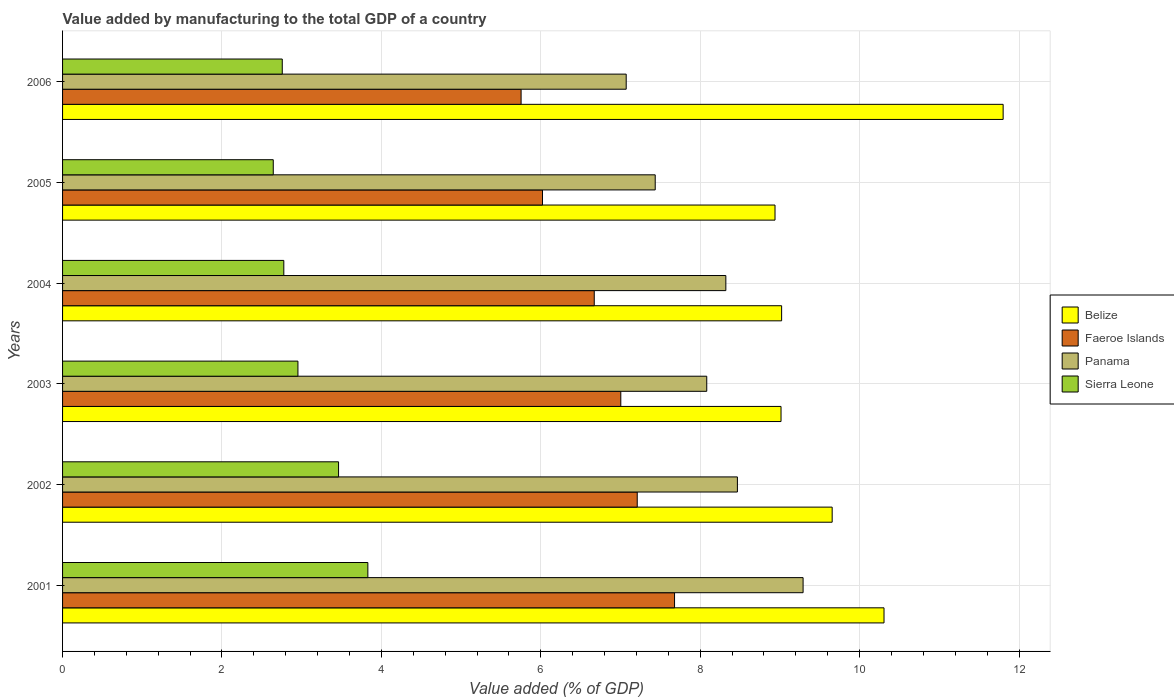How many different coloured bars are there?
Offer a very short reply. 4. How many groups of bars are there?
Offer a terse response. 6. Are the number of bars per tick equal to the number of legend labels?
Provide a short and direct response. Yes. How many bars are there on the 4th tick from the bottom?
Your answer should be very brief. 4. In how many cases, is the number of bars for a given year not equal to the number of legend labels?
Make the answer very short. 0. What is the value added by manufacturing to the total GDP in Faeroe Islands in 2001?
Give a very brief answer. 7.68. Across all years, what is the maximum value added by manufacturing to the total GDP in Sierra Leone?
Give a very brief answer. 3.83. Across all years, what is the minimum value added by manufacturing to the total GDP in Faeroe Islands?
Make the answer very short. 5.75. In which year was the value added by manufacturing to the total GDP in Belize minimum?
Ensure brevity in your answer.  2005. What is the total value added by manufacturing to the total GDP in Panama in the graph?
Give a very brief answer. 48.67. What is the difference between the value added by manufacturing to the total GDP in Sierra Leone in 2002 and that in 2005?
Make the answer very short. 0.82. What is the difference between the value added by manufacturing to the total GDP in Sierra Leone in 2004 and the value added by manufacturing to the total GDP in Faeroe Islands in 2003?
Make the answer very short. -4.23. What is the average value added by manufacturing to the total GDP in Panama per year?
Make the answer very short. 8.11. In the year 2003, what is the difference between the value added by manufacturing to the total GDP in Belize and value added by manufacturing to the total GDP in Faeroe Islands?
Ensure brevity in your answer.  2.01. What is the ratio of the value added by manufacturing to the total GDP in Sierra Leone in 2004 to that in 2005?
Offer a very short reply. 1.05. What is the difference between the highest and the second highest value added by manufacturing to the total GDP in Panama?
Provide a succinct answer. 0.82. What is the difference between the highest and the lowest value added by manufacturing to the total GDP in Belize?
Provide a succinct answer. 2.86. In how many years, is the value added by manufacturing to the total GDP in Panama greater than the average value added by manufacturing to the total GDP in Panama taken over all years?
Offer a terse response. 3. Is it the case that in every year, the sum of the value added by manufacturing to the total GDP in Sierra Leone and value added by manufacturing to the total GDP in Belize is greater than the sum of value added by manufacturing to the total GDP in Panama and value added by manufacturing to the total GDP in Faeroe Islands?
Your answer should be very brief. No. What does the 3rd bar from the top in 2001 represents?
Ensure brevity in your answer.  Faeroe Islands. What does the 4th bar from the bottom in 2005 represents?
Provide a short and direct response. Sierra Leone. Is it the case that in every year, the sum of the value added by manufacturing to the total GDP in Faeroe Islands and value added by manufacturing to the total GDP in Panama is greater than the value added by manufacturing to the total GDP in Belize?
Your response must be concise. Yes. How many bars are there?
Offer a terse response. 24. What is the difference between two consecutive major ticks on the X-axis?
Keep it short and to the point. 2. Does the graph contain grids?
Offer a very short reply. Yes. Where does the legend appear in the graph?
Keep it short and to the point. Center right. How many legend labels are there?
Provide a succinct answer. 4. How are the legend labels stacked?
Provide a short and direct response. Vertical. What is the title of the graph?
Your answer should be very brief. Value added by manufacturing to the total GDP of a country. Does "Panama" appear as one of the legend labels in the graph?
Your answer should be compact. Yes. What is the label or title of the X-axis?
Give a very brief answer. Value added (% of GDP). What is the label or title of the Y-axis?
Give a very brief answer. Years. What is the Value added (% of GDP) of Belize in 2001?
Provide a short and direct response. 10.31. What is the Value added (% of GDP) of Faeroe Islands in 2001?
Make the answer very short. 7.68. What is the Value added (% of GDP) in Panama in 2001?
Offer a very short reply. 9.29. What is the Value added (% of GDP) of Sierra Leone in 2001?
Your answer should be very brief. 3.83. What is the Value added (% of GDP) in Belize in 2002?
Your answer should be very brief. 9.66. What is the Value added (% of GDP) in Faeroe Islands in 2002?
Your answer should be very brief. 7.21. What is the Value added (% of GDP) in Panama in 2002?
Give a very brief answer. 8.47. What is the Value added (% of GDP) in Sierra Leone in 2002?
Provide a short and direct response. 3.46. What is the Value added (% of GDP) of Belize in 2003?
Your answer should be compact. 9.01. What is the Value added (% of GDP) of Faeroe Islands in 2003?
Give a very brief answer. 7. What is the Value added (% of GDP) of Panama in 2003?
Your response must be concise. 8.08. What is the Value added (% of GDP) in Sierra Leone in 2003?
Give a very brief answer. 2.95. What is the Value added (% of GDP) in Belize in 2004?
Give a very brief answer. 9.02. What is the Value added (% of GDP) in Faeroe Islands in 2004?
Offer a very short reply. 6.67. What is the Value added (% of GDP) of Panama in 2004?
Your answer should be compact. 8.32. What is the Value added (% of GDP) of Sierra Leone in 2004?
Make the answer very short. 2.78. What is the Value added (% of GDP) of Belize in 2005?
Make the answer very short. 8.94. What is the Value added (% of GDP) of Faeroe Islands in 2005?
Offer a terse response. 6.02. What is the Value added (% of GDP) in Panama in 2005?
Ensure brevity in your answer.  7.44. What is the Value added (% of GDP) in Sierra Leone in 2005?
Make the answer very short. 2.64. What is the Value added (% of GDP) in Belize in 2006?
Your response must be concise. 11.8. What is the Value added (% of GDP) in Faeroe Islands in 2006?
Offer a terse response. 5.75. What is the Value added (% of GDP) of Panama in 2006?
Ensure brevity in your answer.  7.07. What is the Value added (% of GDP) of Sierra Leone in 2006?
Ensure brevity in your answer.  2.76. Across all years, what is the maximum Value added (% of GDP) of Belize?
Ensure brevity in your answer.  11.8. Across all years, what is the maximum Value added (% of GDP) in Faeroe Islands?
Give a very brief answer. 7.68. Across all years, what is the maximum Value added (% of GDP) in Panama?
Offer a terse response. 9.29. Across all years, what is the maximum Value added (% of GDP) of Sierra Leone?
Ensure brevity in your answer.  3.83. Across all years, what is the minimum Value added (% of GDP) of Belize?
Your answer should be very brief. 8.94. Across all years, what is the minimum Value added (% of GDP) of Faeroe Islands?
Your answer should be compact. 5.75. Across all years, what is the minimum Value added (% of GDP) in Panama?
Your answer should be compact. 7.07. Across all years, what is the minimum Value added (% of GDP) of Sierra Leone?
Provide a short and direct response. 2.64. What is the total Value added (% of GDP) of Belize in the graph?
Your answer should be compact. 58.74. What is the total Value added (% of GDP) of Faeroe Islands in the graph?
Keep it short and to the point. 40.34. What is the total Value added (% of GDP) in Panama in the graph?
Your response must be concise. 48.67. What is the total Value added (% of GDP) in Sierra Leone in the graph?
Provide a short and direct response. 18.42. What is the difference between the Value added (% of GDP) in Belize in 2001 and that in 2002?
Give a very brief answer. 0.65. What is the difference between the Value added (% of GDP) in Faeroe Islands in 2001 and that in 2002?
Ensure brevity in your answer.  0.47. What is the difference between the Value added (% of GDP) of Panama in 2001 and that in 2002?
Make the answer very short. 0.82. What is the difference between the Value added (% of GDP) of Sierra Leone in 2001 and that in 2002?
Ensure brevity in your answer.  0.37. What is the difference between the Value added (% of GDP) in Belize in 2001 and that in 2003?
Your answer should be very brief. 1.29. What is the difference between the Value added (% of GDP) in Faeroe Islands in 2001 and that in 2003?
Give a very brief answer. 0.67. What is the difference between the Value added (% of GDP) in Panama in 2001 and that in 2003?
Your answer should be very brief. 1.21. What is the difference between the Value added (% of GDP) of Sierra Leone in 2001 and that in 2003?
Provide a short and direct response. 0.88. What is the difference between the Value added (% of GDP) in Belize in 2001 and that in 2004?
Make the answer very short. 1.28. What is the difference between the Value added (% of GDP) in Faeroe Islands in 2001 and that in 2004?
Offer a very short reply. 1.01. What is the difference between the Value added (% of GDP) in Panama in 2001 and that in 2004?
Your answer should be very brief. 0.97. What is the difference between the Value added (% of GDP) in Sierra Leone in 2001 and that in 2004?
Give a very brief answer. 1.05. What is the difference between the Value added (% of GDP) of Belize in 2001 and that in 2005?
Your response must be concise. 1.37. What is the difference between the Value added (% of GDP) in Faeroe Islands in 2001 and that in 2005?
Your answer should be compact. 1.66. What is the difference between the Value added (% of GDP) of Panama in 2001 and that in 2005?
Ensure brevity in your answer.  1.86. What is the difference between the Value added (% of GDP) of Sierra Leone in 2001 and that in 2005?
Make the answer very short. 1.19. What is the difference between the Value added (% of GDP) in Belize in 2001 and that in 2006?
Your answer should be compact. -1.49. What is the difference between the Value added (% of GDP) in Faeroe Islands in 2001 and that in 2006?
Offer a terse response. 1.93. What is the difference between the Value added (% of GDP) of Panama in 2001 and that in 2006?
Give a very brief answer. 2.22. What is the difference between the Value added (% of GDP) of Sierra Leone in 2001 and that in 2006?
Keep it short and to the point. 1.07. What is the difference between the Value added (% of GDP) in Belize in 2002 and that in 2003?
Your answer should be compact. 0.64. What is the difference between the Value added (% of GDP) in Faeroe Islands in 2002 and that in 2003?
Provide a succinct answer. 0.21. What is the difference between the Value added (% of GDP) of Panama in 2002 and that in 2003?
Your answer should be very brief. 0.38. What is the difference between the Value added (% of GDP) of Sierra Leone in 2002 and that in 2003?
Your response must be concise. 0.51. What is the difference between the Value added (% of GDP) in Belize in 2002 and that in 2004?
Provide a succinct answer. 0.63. What is the difference between the Value added (% of GDP) in Faeroe Islands in 2002 and that in 2004?
Keep it short and to the point. 0.54. What is the difference between the Value added (% of GDP) of Panama in 2002 and that in 2004?
Your answer should be compact. 0.15. What is the difference between the Value added (% of GDP) of Sierra Leone in 2002 and that in 2004?
Offer a very short reply. 0.69. What is the difference between the Value added (% of GDP) in Belize in 2002 and that in 2005?
Your response must be concise. 0.72. What is the difference between the Value added (% of GDP) of Faeroe Islands in 2002 and that in 2005?
Your answer should be very brief. 1.19. What is the difference between the Value added (% of GDP) in Panama in 2002 and that in 2005?
Your answer should be compact. 1.03. What is the difference between the Value added (% of GDP) in Sierra Leone in 2002 and that in 2005?
Your answer should be compact. 0.82. What is the difference between the Value added (% of GDP) in Belize in 2002 and that in 2006?
Keep it short and to the point. -2.15. What is the difference between the Value added (% of GDP) in Faeroe Islands in 2002 and that in 2006?
Keep it short and to the point. 1.46. What is the difference between the Value added (% of GDP) in Panama in 2002 and that in 2006?
Your answer should be very brief. 1.4. What is the difference between the Value added (% of GDP) of Sierra Leone in 2002 and that in 2006?
Give a very brief answer. 0.71. What is the difference between the Value added (% of GDP) in Belize in 2003 and that in 2004?
Your response must be concise. -0.01. What is the difference between the Value added (% of GDP) of Faeroe Islands in 2003 and that in 2004?
Offer a very short reply. 0.33. What is the difference between the Value added (% of GDP) of Panama in 2003 and that in 2004?
Ensure brevity in your answer.  -0.24. What is the difference between the Value added (% of GDP) in Sierra Leone in 2003 and that in 2004?
Your response must be concise. 0.18. What is the difference between the Value added (% of GDP) of Belize in 2003 and that in 2005?
Provide a succinct answer. 0.08. What is the difference between the Value added (% of GDP) of Faeroe Islands in 2003 and that in 2005?
Ensure brevity in your answer.  0.98. What is the difference between the Value added (% of GDP) of Panama in 2003 and that in 2005?
Provide a short and direct response. 0.65. What is the difference between the Value added (% of GDP) of Sierra Leone in 2003 and that in 2005?
Provide a short and direct response. 0.31. What is the difference between the Value added (% of GDP) in Belize in 2003 and that in 2006?
Your answer should be compact. -2.79. What is the difference between the Value added (% of GDP) in Faeroe Islands in 2003 and that in 2006?
Your answer should be very brief. 1.25. What is the difference between the Value added (% of GDP) of Panama in 2003 and that in 2006?
Provide a short and direct response. 1.01. What is the difference between the Value added (% of GDP) of Sierra Leone in 2003 and that in 2006?
Keep it short and to the point. 0.2. What is the difference between the Value added (% of GDP) in Belize in 2004 and that in 2005?
Provide a short and direct response. 0.08. What is the difference between the Value added (% of GDP) in Faeroe Islands in 2004 and that in 2005?
Give a very brief answer. 0.65. What is the difference between the Value added (% of GDP) of Panama in 2004 and that in 2005?
Make the answer very short. 0.89. What is the difference between the Value added (% of GDP) of Sierra Leone in 2004 and that in 2005?
Make the answer very short. 0.13. What is the difference between the Value added (% of GDP) in Belize in 2004 and that in 2006?
Offer a very short reply. -2.78. What is the difference between the Value added (% of GDP) in Faeroe Islands in 2004 and that in 2006?
Offer a terse response. 0.92. What is the difference between the Value added (% of GDP) in Panama in 2004 and that in 2006?
Provide a short and direct response. 1.25. What is the difference between the Value added (% of GDP) of Sierra Leone in 2004 and that in 2006?
Provide a short and direct response. 0.02. What is the difference between the Value added (% of GDP) of Belize in 2005 and that in 2006?
Your answer should be very brief. -2.86. What is the difference between the Value added (% of GDP) of Faeroe Islands in 2005 and that in 2006?
Your response must be concise. 0.27. What is the difference between the Value added (% of GDP) of Panama in 2005 and that in 2006?
Keep it short and to the point. 0.36. What is the difference between the Value added (% of GDP) in Sierra Leone in 2005 and that in 2006?
Keep it short and to the point. -0.11. What is the difference between the Value added (% of GDP) in Belize in 2001 and the Value added (% of GDP) in Faeroe Islands in 2002?
Your answer should be very brief. 3.1. What is the difference between the Value added (% of GDP) in Belize in 2001 and the Value added (% of GDP) in Panama in 2002?
Offer a terse response. 1.84. What is the difference between the Value added (% of GDP) in Belize in 2001 and the Value added (% of GDP) in Sierra Leone in 2002?
Provide a succinct answer. 6.84. What is the difference between the Value added (% of GDP) of Faeroe Islands in 2001 and the Value added (% of GDP) of Panama in 2002?
Make the answer very short. -0.79. What is the difference between the Value added (% of GDP) of Faeroe Islands in 2001 and the Value added (% of GDP) of Sierra Leone in 2002?
Your answer should be very brief. 4.22. What is the difference between the Value added (% of GDP) of Panama in 2001 and the Value added (% of GDP) of Sierra Leone in 2002?
Provide a succinct answer. 5.83. What is the difference between the Value added (% of GDP) of Belize in 2001 and the Value added (% of GDP) of Faeroe Islands in 2003?
Your response must be concise. 3.3. What is the difference between the Value added (% of GDP) in Belize in 2001 and the Value added (% of GDP) in Panama in 2003?
Provide a succinct answer. 2.22. What is the difference between the Value added (% of GDP) of Belize in 2001 and the Value added (% of GDP) of Sierra Leone in 2003?
Offer a terse response. 7.35. What is the difference between the Value added (% of GDP) in Faeroe Islands in 2001 and the Value added (% of GDP) in Panama in 2003?
Make the answer very short. -0.4. What is the difference between the Value added (% of GDP) of Faeroe Islands in 2001 and the Value added (% of GDP) of Sierra Leone in 2003?
Make the answer very short. 4.72. What is the difference between the Value added (% of GDP) in Panama in 2001 and the Value added (% of GDP) in Sierra Leone in 2003?
Your answer should be very brief. 6.34. What is the difference between the Value added (% of GDP) of Belize in 2001 and the Value added (% of GDP) of Faeroe Islands in 2004?
Offer a terse response. 3.64. What is the difference between the Value added (% of GDP) of Belize in 2001 and the Value added (% of GDP) of Panama in 2004?
Provide a succinct answer. 1.98. What is the difference between the Value added (% of GDP) of Belize in 2001 and the Value added (% of GDP) of Sierra Leone in 2004?
Keep it short and to the point. 7.53. What is the difference between the Value added (% of GDP) of Faeroe Islands in 2001 and the Value added (% of GDP) of Panama in 2004?
Give a very brief answer. -0.64. What is the difference between the Value added (% of GDP) of Faeroe Islands in 2001 and the Value added (% of GDP) of Sierra Leone in 2004?
Provide a short and direct response. 4.9. What is the difference between the Value added (% of GDP) of Panama in 2001 and the Value added (% of GDP) of Sierra Leone in 2004?
Provide a succinct answer. 6.51. What is the difference between the Value added (% of GDP) in Belize in 2001 and the Value added (% of GDP) in Faeroe Islands in 2005?
Offer a very short reply. 4.28. What is the difference between the Value added (% of GDP) of Belize in 2001 and the Value added (% of GDP) of Panama in 2005?
Offer a very short reply. 2.87. What is the difference between the Value added (% of GDP) of Belize in 2001 and the Value added (% of GDP) of Sierra Leone in 2005?
Keep it short and to the point. 7.66. What is the difference between the Value added (% of GDP) of Faeroe Islands in 2001 and the Value added (% of GDP) of Panama in 2005?
Provide a short and direct response. 0.24. What is the difference between the Value added (% of GDP) in Faeroe Islands in 2001 and the Value added (% of GDP) in Sierra Leone in 2005?
Make the answer very short. 5.03. What is the difference between the Value added (% of GDP) of Panama in 2001 and the Value added (% of GDP) of Sierra Leone in 2005?
Offer a very short reply. 6.65. What is the difference between the Value added (% of GDP) of Belize in 2001 and the Value added (% of GDP) of Faeroe Islands in 2006?
Give a very brief answer. 4.55. What is the difference between the Value added (% of GDP) of Belize in 2001 and the Value added (% of GDP) of Panama in 2006?
Your response must be concise. 3.23. What is the difference between the Value added (% of GDP) of Belize in 2001 and the Value added (% of GDP) of Sierra Leone in 2006?
Offer a terse response. 7.55. What is the difference between the Value added (% of GDP) in Faeroe Islands in 2001 and the Value added (% of GDP) in Panama in 2006?
Provide a succinct answer. 0.61. What is the difference between the Value added (% of GDP) in Faeroe Islands in 2001 and the Value added (% of GDP) in Sierra Leone in 2006?
Make the answer very short. 4.92. What is the difference between the Value added (% of GDP) in Panama in 2001 and the Value added (% of GDP) in Sierra Leone in 2006?
Provide a succinct answer. 6.53. What is the difference between the Value added (% of GDP) of Belize in 2002 and the Value added (% of GDP) of Faeroe Islands in 2003?
Give a very brief answer. 2.65. What is the difference between the Value added (% of GDP) in Belize in 2002 and the Value added (% of GDP) in Panama in 2003?
Make the answer very short. 1.57. What is the difference between the Value added (% of GDP) in Belize in 2002 and the Value added (% of GDP) in Sierra Leone in 2003?
Provide a short and direct response. 6.7. What is the difference between the Value added (% of GDP) in Faeroe Islands in 2002 and the Value added (% of GDP) in Panama in 2003?
Offer a very short reply. -0.87. What is the difference between the Value added (% of GDP) in Faeroe Islands in 2002 and the Value added (% of GDP) in Sierra Leone in 2003?
Provide a short and direct response. 4.26. What is the difference between the Value added (% of GDP) of Panama in 2002 and the Value added (% of GDP) of Sierra Leone in 2003?
Provide a short and direct response. 5.51. What is the difference between the Value added (% of GDP) of Belize in 2002 and the Value added (% of GDP) of Faeroe Islands in 2004?
Keep it short and to the point. 2.98. What is the difference between the Value added (% of GDP) in Belize in 2002 and the Value added (% of GDP) in Panama in 2004?
Give a very brief answer. 1.33. What is the difference between the Value added (% of GDP) of Belize in 2002 and the Value added (% of GDP) of Sierra Leone in 2004?
Ensure brevity in your answer.  6.88. What is the difference between the Value added (% of GDP) in Faeroe Islands in 2002 and the Value added (% of GDP) in Panama in 2004?
Offer a very short reply. -1.11. What is the difference between the Value added (% of GDP) in Faeroe Islands in 2002 and the Value added (% of GDP) in Sierra Leone in 2004?
Make the answer very short. 4.43. What is the difference between the Value added (% of GDP) in Panama in 2002 and the Value added (% of GDP) in Sierra Leone in 2004?
Your answer should be compact. 5.69. What is the difference between the Value added (% of GDP) of Belize in 2002 and the Value added (% of GDP) of Faeroe Islands in 2005?
Ensure brevity in your answer.  3.63. What is the difference between the Value added (% of GDP) in Belize in 2002 and the Value added (% of GDP) in Panama in 2005?
Keep it short and to the point. 2.22. What is the difference between the Value added (% of GDP) of Belize in 2002 and the Value added (% of GDP) of Sierra Leone in 2005?
Offer a very short reply. 7.01. What is the difference between the Value added (% of GDP) in Faeroe Islands in 2002 and the Value added (% of GDP) in Panama in 2005?
Your response must be concise. -0.23. What is the difference between the Value added (% of GDP) in Faeroe Islands in 2002 and the Value added (% of GDP) in Sierra Leone in 2005?
Your response must be concise. 4.57. What is the difference between the Value added (% of GDP) in Panama in 2002 and the Value added (% of GDP) in Sierra Leone in 2005?
Offer a very short reply. 5.82. What is the difference between the Value added (% of GDP) in Belize in 2002 and the Value added (% of GDP) in Faeroe Islands in 2006?
Your answer should be very brief. 3.9. What is the difference between the Value added (% of GDP) in Belize in 2002 and the Value added (% of GDP) in Panama in 2006?
Your answer should be very brief. 2.58. What is the difference between the Value added (% of GDP) in Belize in 2002 and the Value added (% of GDP) in Sierra Leone in 2006?
Ensure brevity in your answer.  6.9. What is the difference between the Value added (% of GDP) in Faeroe Islands in 2002 and the Value added (% of GDP) in Panama in 2006?
Ensure brevity in your answer.  0.14. What is the difference between the Value added (% of GDP) in Faeroe Islands in 2002 and the Value added (% of GDP) in Sierra Leone in 2006?
Give a very brief answer. 4.45. What is the difference between the Value added (% of GDP) in Panama in 2002 and the Value added (% of GDP) in Sierra Leone in 2006?
Give a very brief answer. 5.71. What is the difference between the Value added (% of GDP) in Belize in 2003 and the Value added (% of GDP) in Faeroe Islands in 2004?
Your response must be concise. 2.34. What is the difference between the Value added (% of GDP) in Belize in 2003 and the Value added (% of GDP) in Panama in 2004?
Keep it short and to the point. 0.69. What is the difference between the Value added (% of GDP) in Belize in 2003 and the Value added (% of GDP) in Sierra Leone in 2004?
Your answer should be very brief. 6.24. What is the difference between the Value added (% of GDP) of Faeroe Islands in 2003 and the Value added (% of GDP) of Panama in 2004?
Your response must be concise. -1.32. What is the difference between the Value added (% of GDP) in Faeroe Islands in 2003 and the Value added (% of GDP) in Sierra Leone in 2004?
Keep it short and to the point. 4.23. What is the difference between the Value added (% of GDP) of Panama in 2003 and the Value added (% of GDP) of Sierra Leone in 2004?
Give a very brief answer. 5.31. What is the difference between the Value added (% of GDP) in Belize in 2003 and the Value added (% of GDP) in Faeroe Islands in 2005?
Your response must be concise. 2.99. What is the difference between the Value added (% of GDP) of Belize in 2003 and the Value added (% of GDP) of Panama in 2005?
Keep it short and to the point. 1.58. What is the difference between the Value added (% of GDP) in Belize in 2003 and the Value added (% of GDP) in Sierra Leone in 2005?
Offer a very short reply. 6.37. What is the difference between the Value added (% of GDP) of Faeroe Islands in 2003 and the Value added (% of GDP) of Panama in 2005?
Offer a terse response. -0.43. What is the difference between the Value added (% of GDP) in Faeroe Islands in 2003 and the Value added (% of GDP) in Sierra Leone in 2005?
Your answer should be very brief. 4.36. What is the difference between the Value added (% of GDP) in Panama in 2003 and the Value added (% of GDP) in Sierra Leone in 2005?
Provide a short and direct response. 5.44. What is the difference between the Value added (% of GDP) in Belize in 2003 and the Value added (% of GDP) in Faeroe Islands in 2006?
Provide a short and direct response. 3.26. What is the difference between the Value added (% of GDP) of Belize in 2003 and the Value added (% of GDP) of Panama in 2006?
Your response must be concise. 1.94. What is the difference between the Value added (% of GDP) of Belize in 2003 and the Value added (% of GDP) of Sierra Leone in 2006?
Your answer should be very brief. 6.26. What is the difference between the Value added (% of GDP) in Faeroe Islands in 2003 and the Value added (% of GDP) in Panama in 2006?
Give a very brief answer. -0.07. What is the difference between the Value added (% of GDP) of Faeroe Islands in 2003 and the Value added (% of GDP) of Sierra Leone in 2006?
Offer a terse response. 4.25. What is the difference between the Value added (% of GDP) of Panama in 2003 and the Value added (% of GDP) of Sierra Leone in 2006?
Your answer should be very brief. 5.33. What is the difference between the Value added (% of GDP) of Belize in 2004 and the Value added (% of GDP) of Faeroe Islands in 2005?
Your response must be concise. 3. What is the difference between the Value added (% of GDP) in Belize in 2004 and the Value added (% of GDP) in Panama in 2005?
Offer a very short reply. 1.59. What is the difference between the Value added (% of GDP) of Belize in 2004 and the Value added (% of GDP) of Sierra Leone in 2005?
Offer a terse response. 6.38. What is the difference between the Value added (% of GDP) of Faeroe Islands in 2004 and the Value added (% of GDP) of Panama in 2005?
Your answer should be very brief. -0.76. What is the difference between the Value added (% of GDP) in Faeroe Islands in 2004 and the Value added (% of GDP) in Sierra Leone in 2005?
Ensure brevity in your answer.  4.03. What is the difference between the Value added (% of GDP) of Panama in 2004 and the Value added (% of GDP) of Sierra Leone in 2005?
Give a very brief answer. 5.68. What is the difference between the Value added (% of GDP) of Belize in 2004 and the Value added (% of GDP) of Faeroe Islands in 2006?
Make the answer very short. 3.27. What is the difference between the Value added (% of GDP) of Belize in 2004 and the Value added (% of GDP) of Panama in 2006?
Provide a succinct answer. 1.95. What is the difference between the Value added (% of GDP) in Belize in 2004 and the Value added (% of GDP) in Sierra Leone in 2006?
Ensure brevity in your answer.  6.26. What is the difference between the Value added (% of GDP) in Faeroe Islands in 2004 and the Value added (% of GDP) in Panama in 2006?
Ensure brevity in your answer.  -0.4. What is the difference between the Value added (% of GDP) in Faeroe Islands in 2004 and the Value added (% of GDP) in Sierra Leone in 2006?
Your answer should be very brief. 3.91. What is the difference between the Value added (% of GDP) of Panama in 2004 and the Value added (% of GDP) of Sierra Leone in 2006?
Ensure brevity in your answer.  5.57. What is the difference between the Value added (% of GDP) in Belize in 2005 and the Value added (% of GDP) in Faeroe Islands in 2006?
Give a very brief answer. 3.19. What is the difference between the Value added (% of GDP) in Belize in 2005 and the Value added (% of GDP) in Panama in 2006?
Keep it short and to the point. 1.87. What is the difference between the Value added (% of GDP) in Belize in 2005 and the Value added (% of GDP) in Sierra Leone in 2006?
Offer a terse response. 6.18. What is the difference between the Value added (% of GDP) of Faeroe Islands in 2005 and the Value added (% of GDP) of Panama in 2006?
Give a very brief answer. -1.05. What is the difference between the Value added (% of GDP) in Faeroe Islands in 2005 and the Value added (% of GDP) in Sierra Leone in 2006?
Give a very brief answer. 3.26. What is the difference between the Value added (% of GDP) of Panama in 2005 and the Value added (% of GDP) of Sierra Leone in 2006?
Provide a succinct answer. 4.68. What is the average Value added (% of GDP) of Belize per year?
Offer a terse response. 9.79. What is the average Value added (% of GDP) in Faeroe Islands per year?
Your answer should be compact. 6.72. What is the average Value added (% of GDP) of Panama per year?
Keep it short and to the point. 8.11. What is the average Value added (% of GDP) of Sierra Leone per year?
Offer a very short reply. 3.07. In the year 2001, what is the difference between the Value added (% of GDP) in Belize and Value added (% of GDP) in Faeroe Islands?
Offer a very short reply. 2.63. In the year 2001, what is the difference between the Value added (% of GDP) in Belize and Value added (% of GDP) in Panama?
Ensure brevity in your answer.  1.02. In the year 2001, what is the difference between the Value added (% of GDP) of Belize and Value added (% of GDP) of Sierra Leone?
Provide a short and direct response. 6.48. In the year 2001, what is the difference between the Value added (% of GDP) in Faeroe Islands and Value added (% of GDP) in Panama?
Your answer should be very brief. -1.61. In the year 2001, what is the difference between the Value added (% of GDP) of Faeroe Islands and Value added (% of GDP) of Sierra Leone?
Ensure brevity in your answer.  3.85. In the year 2001, what is the difference between the Value added (% of GDP) of Panama and Value added (% of GDP) of Sierra Leone?
Offer a very short reply. 5.46. In the year 2002, what is the difference between the Value added (% of GDP) of Belize and Value added (% of GDP) of Faeroe Islands?
Ensure brevity in your answer.  2.45. In the year 2002, what is the difference between the Value added (% of GDP) of Belize and Value added (% of GDP) of Panama?
Keep it short and to the point. 1.19. In the year 2002, what is the difference between the Value added (% of GDP) in Belize and Value added (% of GDP) in Sierra Leone?
Offer a terse response. 6.19. In the year 2002, what is the difference between the Value added (% of GDP) of Faeroe Islands and Value added (% of GDP) of Panama?
Make the answer very short. -1.26. In the year 2002, what is the difference between the Value added (% of GDP) of Faeroe Islands and Value added (% of GDP) of Sierra Leone?
Your answer should be very brief. 3.75. In the year 2002, what is the difference between the Value added (% of GDP) of Panama and Value added (% of GDP) of Sierra Leone?
Your answer should be very brief. 5. In the year 2003, what is the difference between the Value added (% of GDP) in Belize and Value added (% of GDP) in Faeroe Islands?
Offer a terse response. 2.01. In the year 2003, what is the difference between the Value added (% of GDP) of Belize and Value added (% of GDP) of Panama?
Make the answer very short. 0.93. In the year 2003, what is the difference between the Value added (% of GDP) of Belize and Value added (% of GDP) of Sierra Leone?
Your answer should be compact. 6.06. In the year 2003, what is the difference between the Value added (% of GDP) of Faeroe Islands and Value added (% of GDP) of Panama?
Give a very brief answer. -1.08. In the year 2003, what is the difference between the Value added (% of GDP) in Faeroe Islands and Value added (% of GDP) in Sierra Leone?
Your response must be concise. 4.05. In the year 2003, what is the difference between the Value added (% of GDP) in Panama and Value added (% of GDP) in Sierra Leone?
Your answer should be very brief. 5.13. In the year 2004, what is the difference between the Value added (% of GDP) of Belize and Value added (% of GDP) of Faeroe Islands?
Your answer should be compact. 2.35. In the year 2004, what is the difference between the Value added (% of GDP) of Belize and Value added (% of GDP) of Panama?
Provide a succinct answer. 0.7. In the year 2004, what is the difference between the Value added (% of GDP) of Belize and Value added (% of GDP) of Sierra Leone?
Your response must be concise. 6.25. In the year 2004, what is the difference between the Value added (% of GDP) of Faeroe Islands and Value added (% of GDP) of Panama?
Give a very brief answer. -1.65. In the year 2004, what is the difference between the Value added (% of GDP) of Faeroe Islands and Value added (% of GDP) of Sierra Leone?
Keep it short and to the point. 3.89. In the year 2004, what is the difference between the Value added (% of GDP) of Panama and Value added (% of GDP) of Sierra Leone?
Give a very brief answer. 5.55. In the year 2005, what is the difference between the Value added (% of GDP) in Belize and Value added (% of GDP) in Faeroe Islands?
Your response must be concise. 2.92. In the year 2005, what is the difference between the Value added (% of GDP) in Belize and Value added (% of GDP) in Panama?
Give a very brief answer. 1.5. In the year 2005, what is the difference between the Value added (% of GDP) in Belize and Value added (% of GDP) in Sierra Leone?
Your answer should be very brief. 6.3. In the year 2005, what is the difference between the Value added (% of GDP) of Faeroe Islands and Value added (% of GDP) of Panama?
Your answer should be compact. -1.41. In the year 2005, what is the difference between the Value added (% of GDP) of Faeroe Islands and Value added (% of GDP) of Sierra Leone?
Provide a short and direct response. 3.38. In the year 2005, what is the difference between the Value added (% of GDP) in Panama and Value added (% of GDP) in Sierra Leone?
Offer a terse response. 4.79. In the year 2006, what is the difference between the Value added (% of GDP) of Belize and Value added (% of GDP) of Faeroe Islands?
Your answer should be compact. 6.05. In the year 2006, what is the difference between the Value added (% of GDP) in Belize and Value added (% of GDP) in Panama?
Provide a succinct answer. 4.73. In the year 2006, what is the difference between the Value added (% of GDP) in Belize and Value added (% of GDP) in Sierra Leone?
Your answer should be very brief. 9.04. In the year 2006, what is the difference between the Value added (% of GDP) in Faeroe Islands and Value added (% of GDP) in Panama?
Give a very brief answer. -1.32. In the year 2006, what is the difference between the Value added (% of GDP) of Faeroe Islands and Value added (% of GDP) of Sierra Leone?
Provide a succinct answer. 3. In the year 2006, what is the difference between the Value added (% of GDP) of Panama and Value added (% of GDP) of Sierra Leone?
Keep it short and to the point. 4.32. What is the ratio of the Value added (% of GDP) of Belize in 2001 to that in 2002?
Your response must be concise. 1.07. What is the ratio of the Value added (% of GDP) in Faeroe Islands in 2001 to that in 2002?
Your answer should be very brief. 1.06. What is the ratio of the Value added (% of GDP) of Panama in 2001 to that in 2002?
Ensure brevity in your answer.  1.1. What is the ratio of the Value added (% of GDP) in Sierra Leone in 2001 to that in 2002?
Offer a terse response. 1.11. What is the ratio of the Value added (% of GDP) of Belize in 2001 to that in 2003?
Offer a very short reply. 1.14. What is the ratio of the Value added (% of GDP) of Faeroe Islands in 2001 to that in 2003?
Make the answer very short. 1.1. What is the ratio of the Value added (% of GDP) in Panama in 2001 to that in 2003?
Provide a short and direct response. 1.15. What is the ratio of the Value added (% of GDP) in Sierra Leone in 2001 to that in 2003?
Your response must be concise. 1.3. What is the ratio of the Value added (% of GDP) in Belize in 2001 to that in 2004?
Ensure brevity in your answer.  1.14. What is the ratio of the Value added (% of GDP) in Faeroe Islands in 2001 to that in 2004?
Offer a very short reply. 1.15. What is the ratio of the Value added (% of GDP) in Panama in 2001 to that in 2004?
Make the answer very short. 1.12. What is the ratio of the Value added (% of GDP) in Sierra Leone in 2001 to that in 2004?
Ensure brevity in your answer.  1.38. What is the ratio of the Value added (% of GDP) of Belize in 2001 to that in 2005?
Provide a short and direct response. 1.15. What is the ratio of the Value added (% of GDP) in Faeroe Islands in 2001 to that in 2005?
Provide a succinct answer. 1.28. What is the ratio of the Value added (% of GDP) in Panama in 2001 to that in 2005?
Your answer should be compact. 1.25. What is the ratio of the Value added (% of GDP) of Sierra Leone in 2001 to that in 2005?
Your answer should be compact. 1.45. What is the ratio of the Value added (% of GDP) in Belize in 2001 to that in 2006?
Provide a succinct answer. 0.87. What is the ratio of the Value added (% of GDP) of Faeroe Islands in 2001 to that in 2006?
Your response must be concise. 1.33. What is the ratio of the Value added (% of GDP) in Panama in 2001 to that in 2006?
Your response must be concise. 1.31. What is the ratio of the Value added (% of GDP) in Sierra Leone in 2001 to that in 2006?
Provide a short and direct response. 1.39. What is the ratio of the Value added (% of GDP) in Belize in 2002 to that in 2003?
Make the answer very short. 1.07. What is the ratio of the Value added (% of GDP) of Faeroe Islands in 2002 to that in 2003?
Offer a very short reply. 1.03. What is the ratio of the Value added (% of GDP) of Panama in 2002 to that in 2003?
Provide a short and direct response. 1.05. What is the ratio of the Value added (% of GDP) of Sierra Leone in 2002 to that in 2003?
Offer a terse response. 1.17. What is the ratio of the Value added (% of GDP) in Belize in 2002 to that in 2004?
Your answer should be compact. 1.07. What is the ratio of the Value added (% of GDP) in Faeroe Islands in 2002 to that in 2004?
Ensure brevity in your answer.  1.08. What is the ratio of the Value added (% of GDP) of Panama in 2002 to that in 2004?
Your answer should be very brief. 1.02. What is the ratio of the Value added (% of GDP) of Sierra Leone in 2002 to that in 2004?
Make the answer very short. 1.25. What is the ratio of the Value added (% of GDP) in Belize in 2002 to that in 2005?
Ensure brevity in your answer.  1.08. What is the ratio of the Value added (% of GDP) in Faeroe Islands in 2002 to that in 2005?
Give a very brief answer. 1.2. What is the ratio of the Value added (% of GDP) in Panama in 2002 to that in 2005?
Ensure brevity in your answer.  1.14. What is the ratio of the Value added (% of GDP) of Sierra Leone in 2002 to that in 2005?
Offer a terse response. 1.31. What is the ratio of the Value added (% of GDP) of Belize in 2002 to that in 2006?
Make the answer very short. 0.82. What is the ratio of the Value added (% of GDP) in Faeroe Islands in 2002 to that in 2006?
Your response must be concise. 1.25. What is the ratio of the Value added (% of GDP) in Panama in 2002 to that in 2006?
Ensure brevity in your answer.  1.2. What is the ratio of the Value added (% of GDP) in Sierra Leone in 2002 to that in 2006?
Ensure brevity in your answer.  1.26. What is the ratio of the Value added (% of GDP) in Belize in 2003 to that in 2004?
Provide a succinct answer. 1. What is the ratio of the Value added (% of GDP) of Faeroe Islands in 2003 to that in 2004?
Your response must be concise. 1.05. What is the ratio of the Value added (% of GDP) of Panama in 2003 to that in 2004?
Give a very brief answer. 0.97. What is the ratio of the Value added (% of GDP) in Sierra Leone in 2003 to that in 2004?
Provide a short and direct response. 1.06. What is the ratio of the Value added (% of GDP) in Belize in 2003 to that in 2005?
Ensure brevity in your answer.  1.01. What is the ratio of the Value added (% of GDP) in Faeroe Islands in 2003 to that in 2005?
Offer a terse response. 1.16. What is the ratio of the Value added (% of GDP) of Panama in 2003 to that in 2005?
Make the answer very short. 1.09. What is the ratio of the Value added (% of GDP) of Sierra Leone in 2003 to that in 2005?
Give a very brief answer. 1.12. What is the ratio of the Value added (% of GDP) in Belize in 2003 to that in 2006?
Ensure brevity in your answer.  0.76. What is the ratio of the Value added (% of GDP) in Faeroe Islands in 2003 to that in 2006?
Your answer should be very brief. 1.22. What is the ratio of the Value added (% of GDP) in Sierra Leone in 2003 to that in 2006?
Give a very brief answer. 1.07. What is the ratio of the Value added (% of GDP) of Belize in 2004 to that in 2005?
Keep it short and to the point. 1.01. What is the ratio of the Value added (% of GDP) in Faeroe Islands in 2004 to that in 2005?
Provide a succinct answer. 1.11. What is the ratio of the Value added (% of GDP) in Panama in 2004 to that in 2005?
Give a very brief answer. 1.12. What is the ratio of the Value added (% of GDP) of Sierra Leone in 2004 to that in 2005?
Ensure brevity in your answer.  1.05. What is the ratio of the Value added (% of GDP) in Belize in 2004 to that in 2006?
Your response must be concise. 0.76. What is the ratio of the Value added (% of GDP) in Faeroe Islands in 2004 to that in 2006?
Your response must be concise. 1.16. What is the ratio of the Value added (% of GDP) of Panama in 2004 to that in 2006?
Give a very brief answer. 1.18. What is the ratio of the Value added (% of GDP) of Sierra Leone in 2004 to that in 2006?
Give a very brief answer. 1.01. What is the ratio of the Value added (% of GDP) in Belize in 2005 to that in 2006?
Keep it short and to the point. 0.76. What is the ratio of the Value added (% of GDP) of Faeroe Islands in 2005 to that in 2006?
Offer a terse response. 1.05. What is the ratio of the Value added (% of GDP) in Panama in 2005 to that in 2006?
Provide a short and direct response. 1.05. What is the ratio of the Value added (% of GDP) of Sierra Leone in 2005 to that in 2006?
Provide a succinct answer. 0.96. What is the difference between the highest and the second highest Value added (% of GDP) in Belize?
Keep it short and to the point. 1.49. What is the difference between the highest and the second highest Value added (% of GDP) of Faeroe Islands?
Give a very brief answer. 0.47. What is the difference between the highest and the second highest Value added (% of GDP) in Panama?
Offer a very short reply. 0.82. What is the difference between the highest and the second highest Value added (% of GDP) in Sierra Leone?
Ensure brevity in your answer.  0.37. What is the difference between the highest and the lowest Value added (% of GDP) in Belize?
Ensure brevity in your answer.  2.86. What is the difference between the highest and the lowest Value added (% of GDP) of Faeroe Islands?
Provide a succinct answer. 1.93. What is the difference between the highest and the lowest Value added (% of GDP) in Panama?
Offer a terse response. 2.22. What is the difference between the highest and the lowest Value added (% of GDP) of Sierra Leone?
Provide a short and direct response. 1.19. 